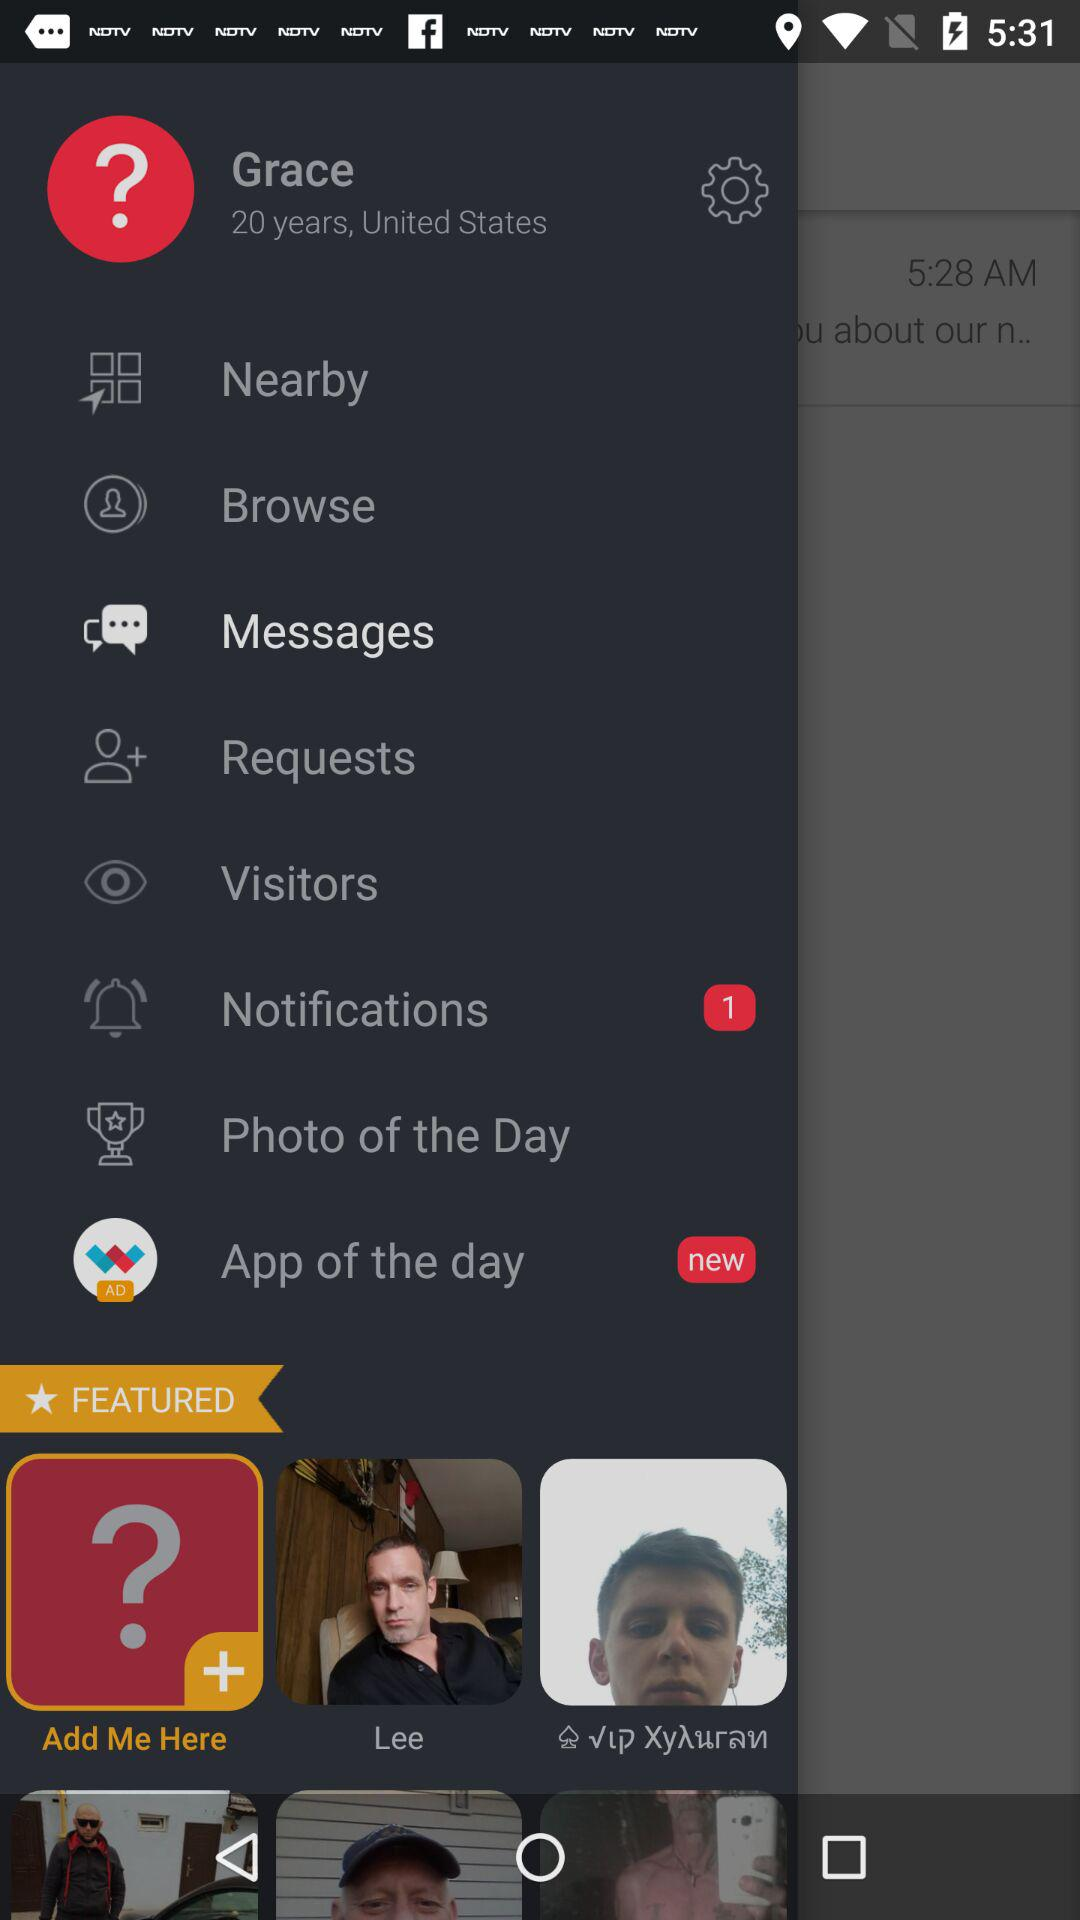What is the profile name? The profile name is Grace. 